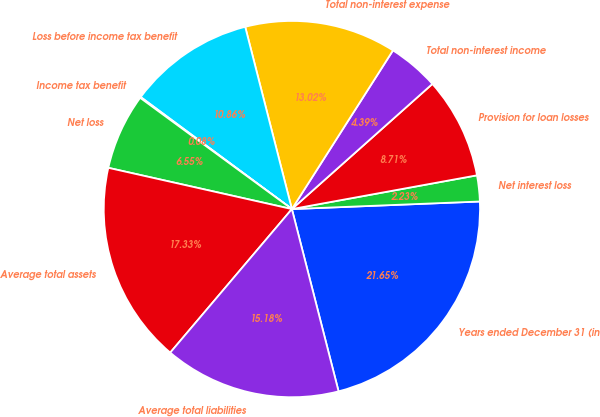Convert chart to OTSL. <chart><loc_0><loc_0><loc_500><loc_500><pie_chart><fcel>Years ended December 31 (in<fcel>Net interest loss<fcel>Provision for loan losses<fcel>Total non-interest income<fcel>Total non-interest expense<fcel>Loss before income tax benefit<fcel>Income tax benefit<fcel>Net loss<fcel>Average total assets<fcel>Average total liabilities<nl><fcel>21.65%<fcel>2.23%<fcel>8.71%<fcel>4.39%<fcel>13.02%<fcel>10.86%<fcel>0.08%<fcel>6.55%<fcel>17.33%<fcel>15.18%<nl></chart> 